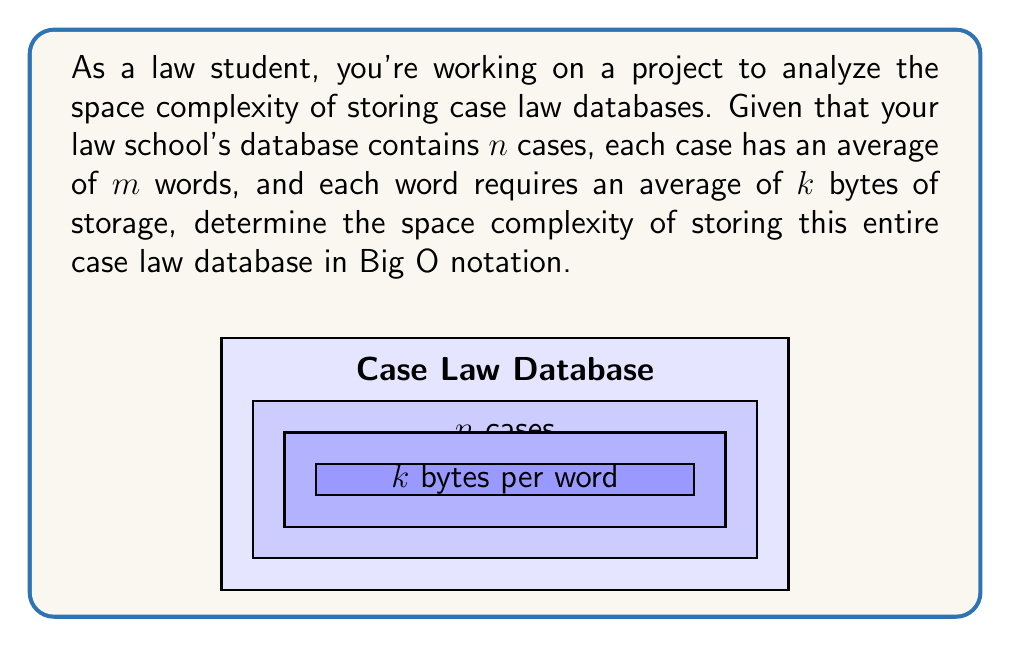Solve this math problem. To determine the space complexity, we need to follow these steps:

1) First, let's calculate the space required for a single case:
   - Each case has $m$ words on average
   - Each word requires $k$ bytes of storage
   - So, a single case requires $m * k$ bytes

2) Now, we have $n$ cases in total:
   - Total space = (Space per case) * (Number of cases)
   - Total space = $(m * k) * n$ bytes

3) In Big O notation, we're interested in how the space requirement grows with respect to the input size. Here, our input size is primarily determined by the number of cases, $n$.

4) The variables $m$ and $k$ are typically considered constants in this context, as they represent the average word count per case and average bytes per word, which don't tend to grow with the number of cases.

5) Therefore, we can simplify our expression:
   $O((m * k) * n)$ = $O(n)$

This is because in Big O notation, we drop constant factors (like $m * k$).
Answer: $O(n)$ 